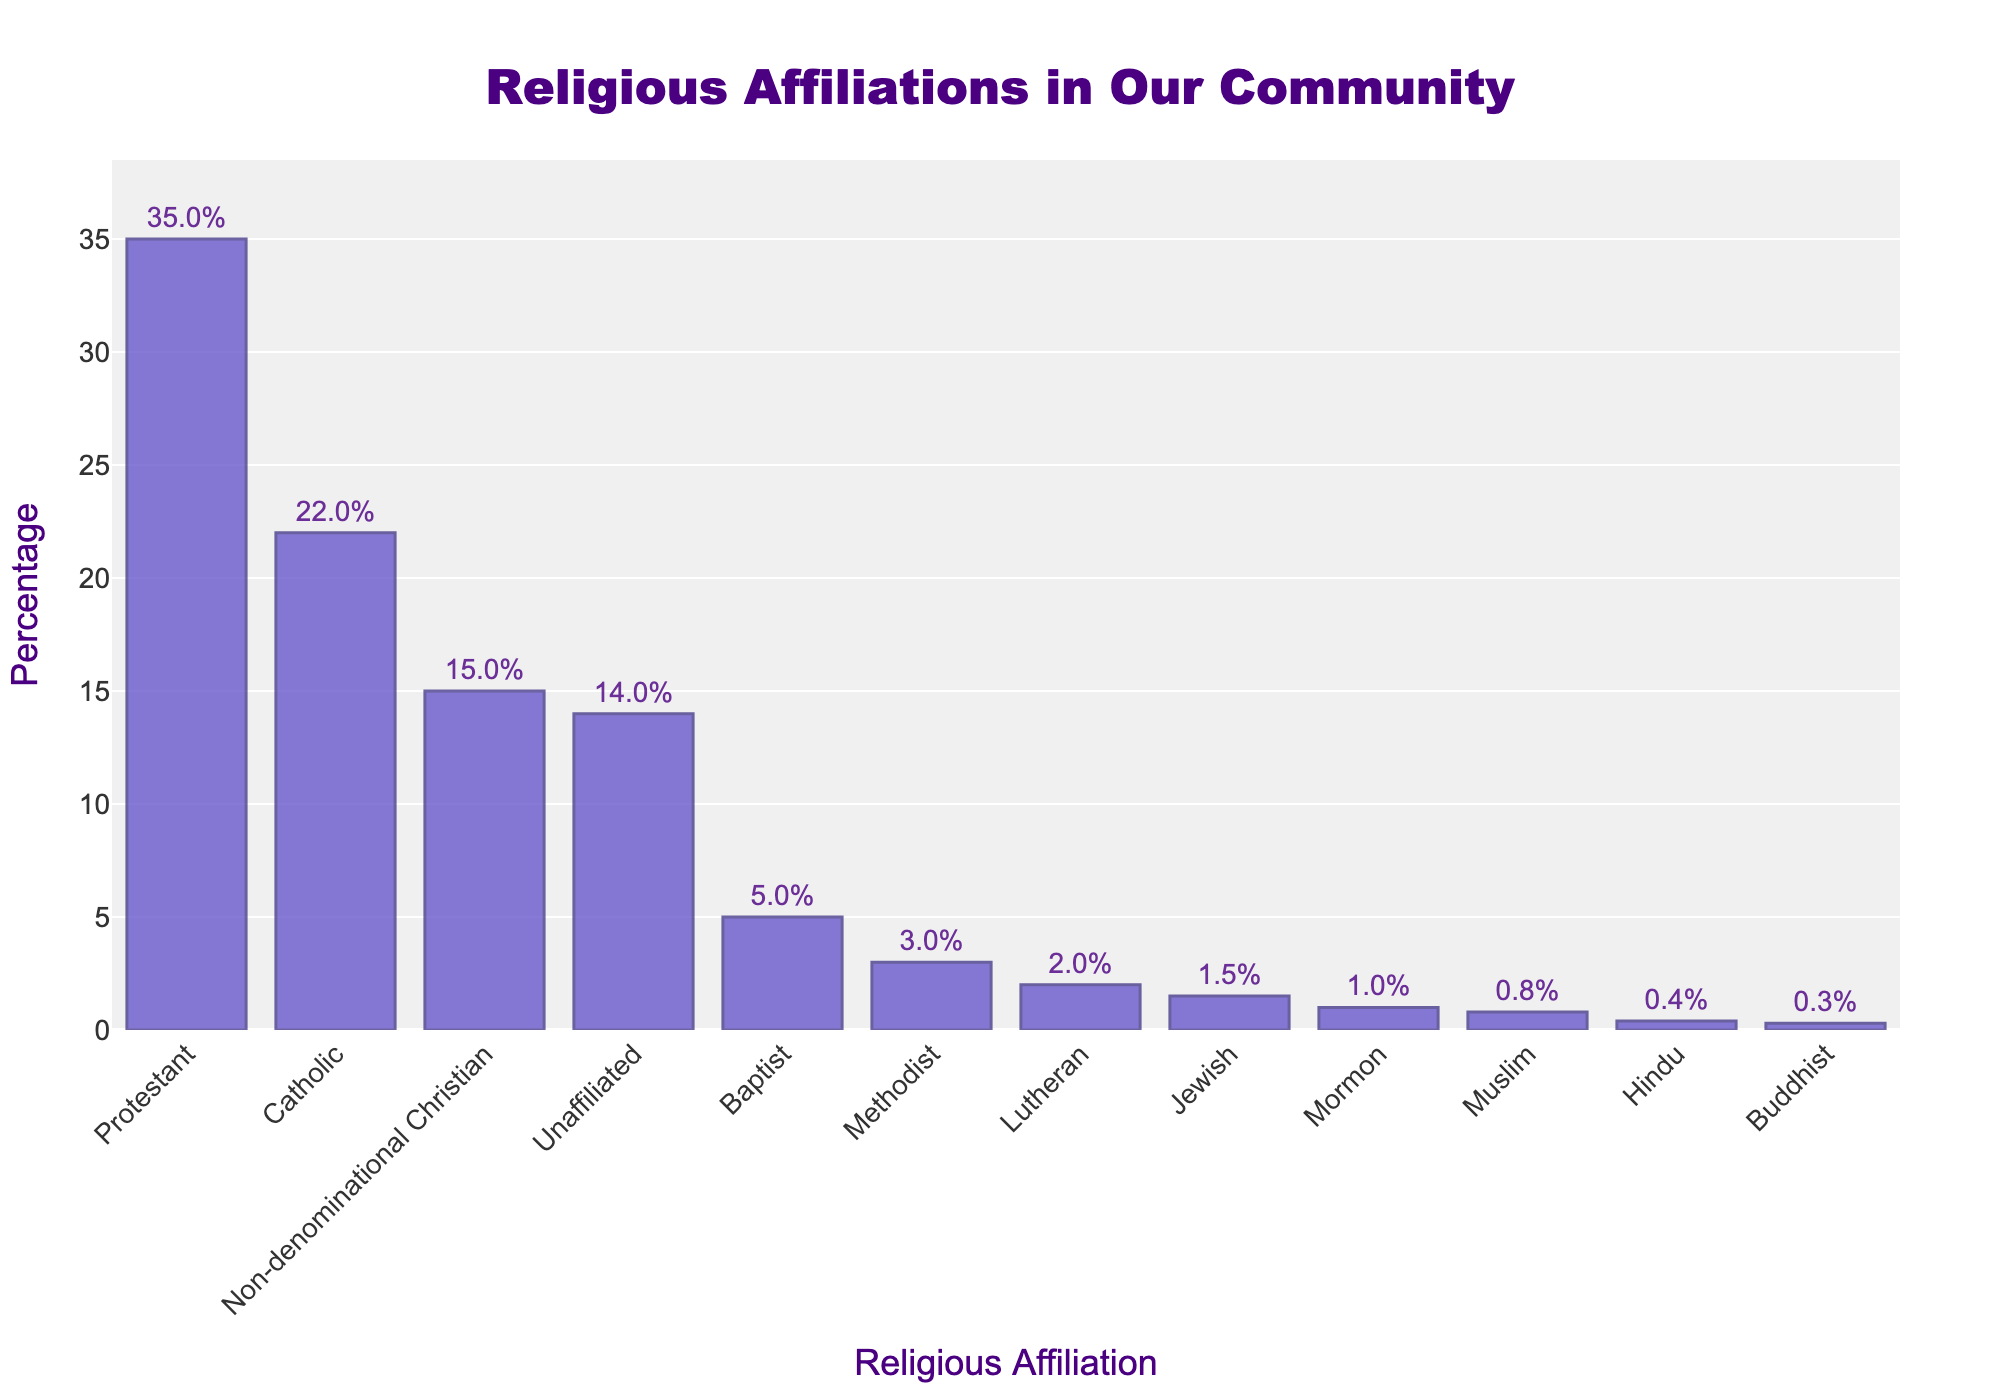Which religious affiliation has the highest percentage? The bar corresponding to Protestant is the tallest in the figure, indicating it has the highest percentage.
Answer: Protestant Which two religious affiliations have the lowest percentages? The bars for Buddhist and Hindu are the shortest in the figure, indicating they have the lowest percentages.
Answer: Buddhist and Hindu What is the combined percentage of Protestant and Catholic affiliations? The percentage of Protestant is 35, and Catholic is 22. Adding them together gives us 35 + 22 = 57.
Answer: 57 How much greater is the percentage of Unaffiliated compared to Baptist? The percentage of Unaffiliated is 14 and Baptist is 5. The difference is 14 - 5 = 9.
Answer: 9 What is the average percentage of the top three religious affiliations? The top three affiliations by percentage are Protestant (35), Catholic (22), and Non-denominational Christian (15). The sum of these percentages is 35 + 22 + 15 = 72. Average is 72 / 3 = 24.
Answer: 24 How many religious affiliations have a percentage lower than 5? By examining the bars, Methodist (3), Lutheran (2), Jewish (1.5), Mormon (1), Muslim (0.8), Hindu (0.4), and Buddhist (0.3) all have percentages lower than 5. Therefore, there are 7 such affiliations.
Answer: 7 Is the percentage of Non-denominational Christian greater or less than the sum of Methodist and Lutheran? The percentage of Non-denominational Christian is 15. The sum of Methodist and Lutheran is 3 + 2 = 5. Since 15 is greater than 5, Non-denominational Christian is greater.
Answer: Greater Does any religious affiliation have a percentage exactly double another affiliation? The percentage of Lutheran (2) is exactly double that of Hindu (0.4). Also, the percentage of Baptist (5) is double that of Lutheran (2.5).
Answer: Yes What is the total percentage of all affiliations that have a percentage above 10? The affiliations above 10 are Protestant (35), Catholic (22), Non-denominational Christian (15), and Unaffiliated (14). Their total is 35 + 22 + 15 + 14 = 86.
Answer: 86 By how much does the percentage of Non-denominational Christian exceed that of Methodist and Lutheran combined? The percentage of Non-denominational Christian is 15. The combined percentage of Methodist and Lutheran is 3 + 2 = 5. The difference is 15 - 5 = 10.
Answer: 10 